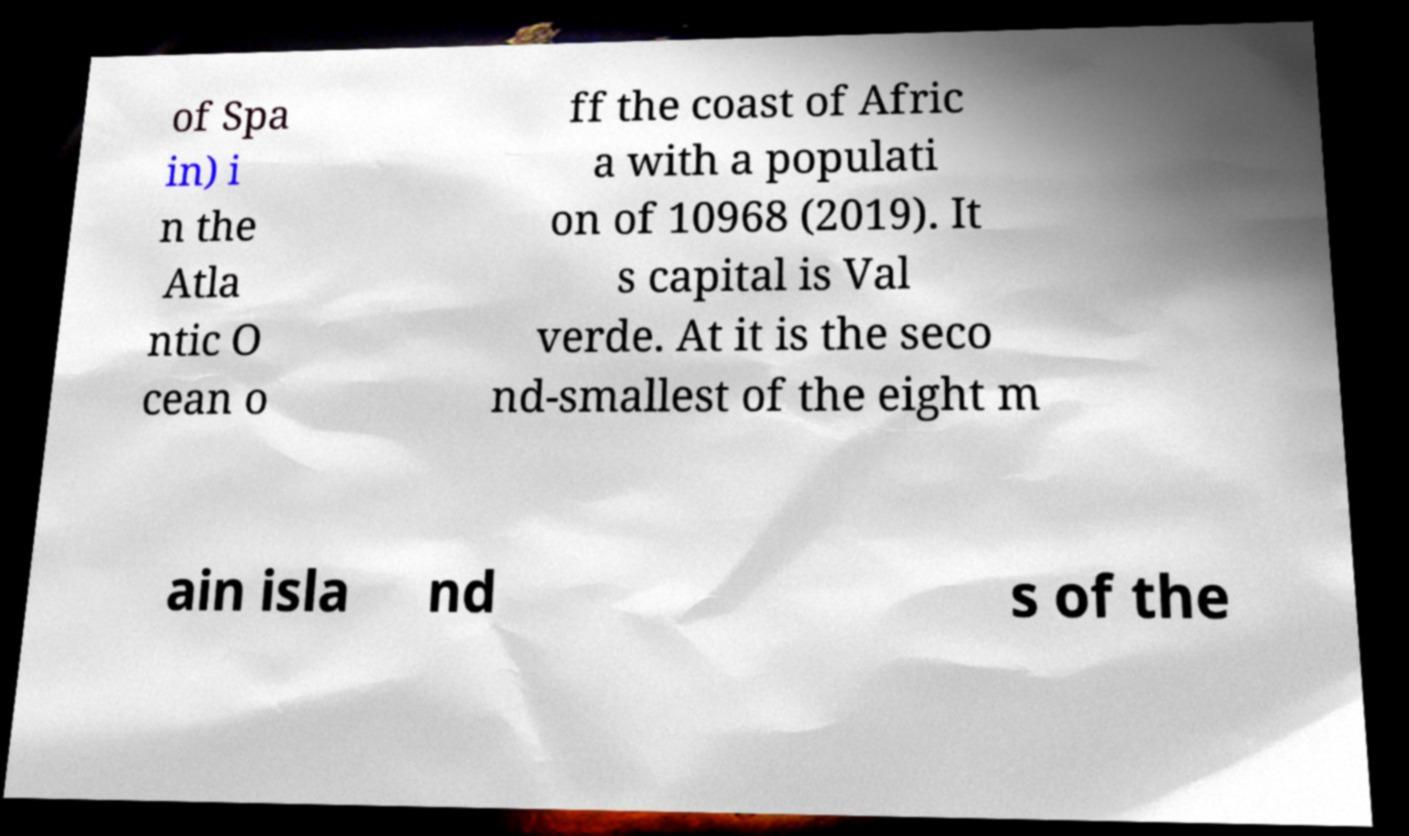Can you accurately transcribe the text from the provided image for me? of Spa in) i n the Atla ntic O cean o ff the coast of Afric a with a populati on of 10968 (2019). It s capital is Val verde. At it is the seco nd-smallest of the eight m ain isla nd s of the 